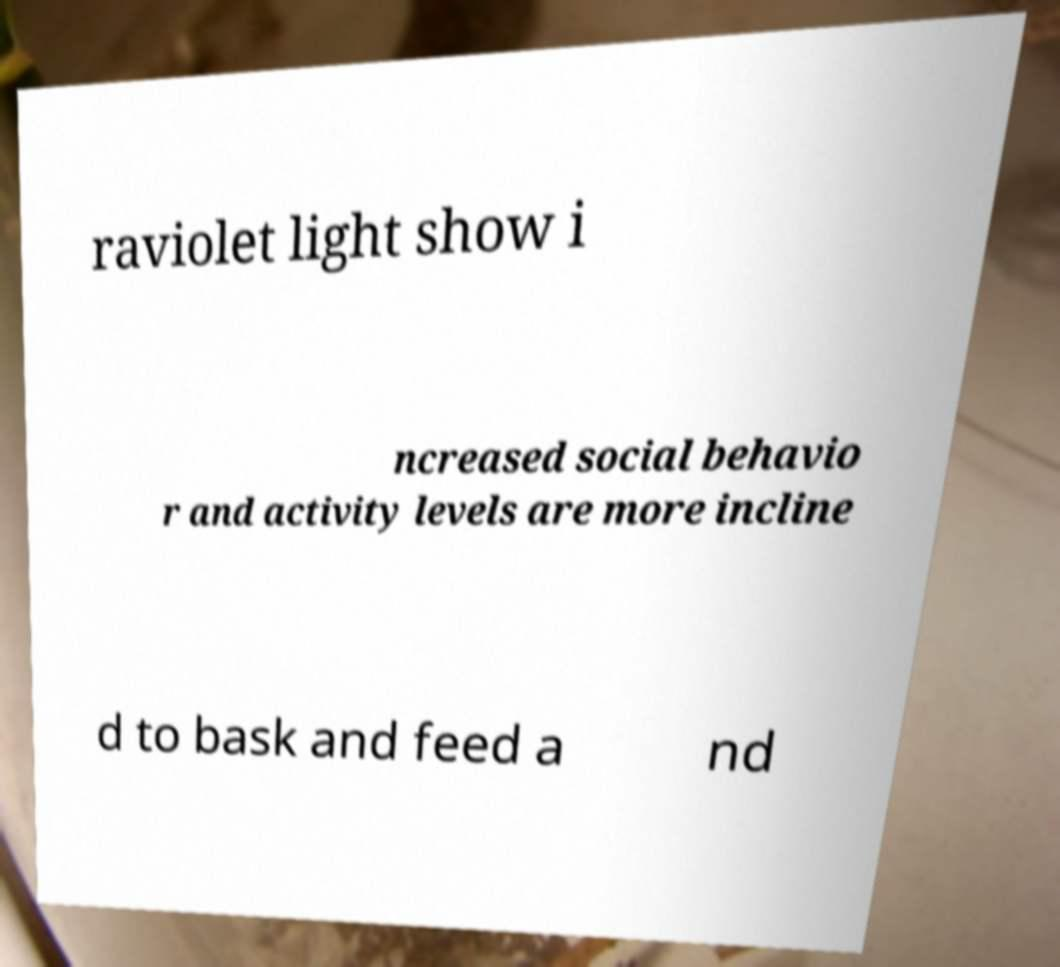I need the written content from this picture converted into text. Can you do that? raviolet light show i ncreased social behavio r and activity levels are more incline d to bask and feed a nd 